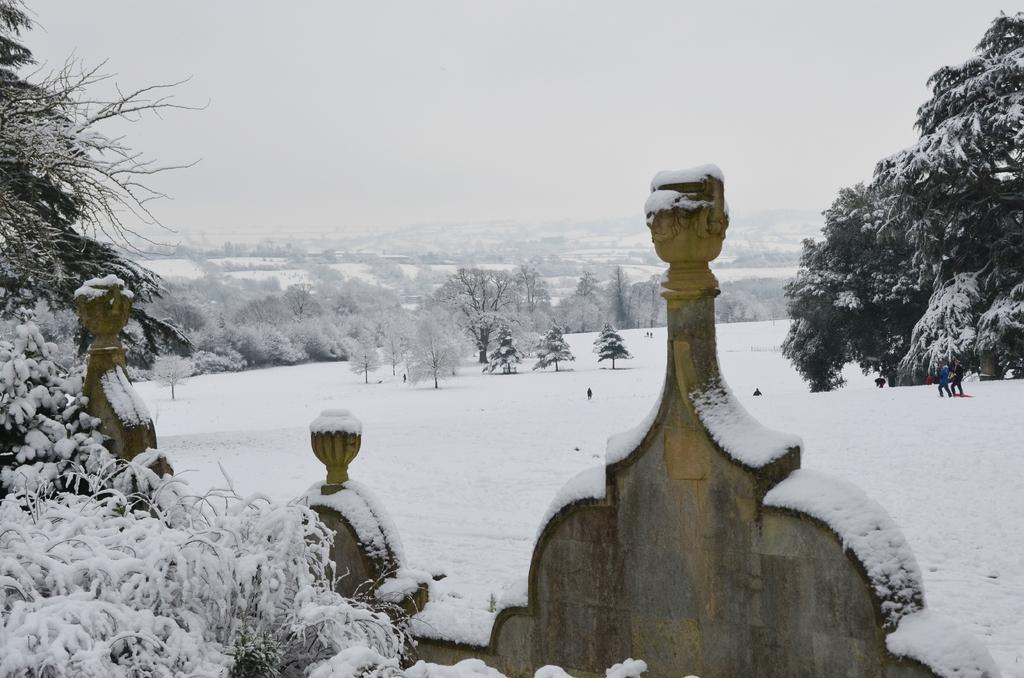How would you summarize this image in a sentence or two? In this picture, it looks like a wall. Behind the wall there are two people on the snow. Behind the people there are trees, hills and the sky. 